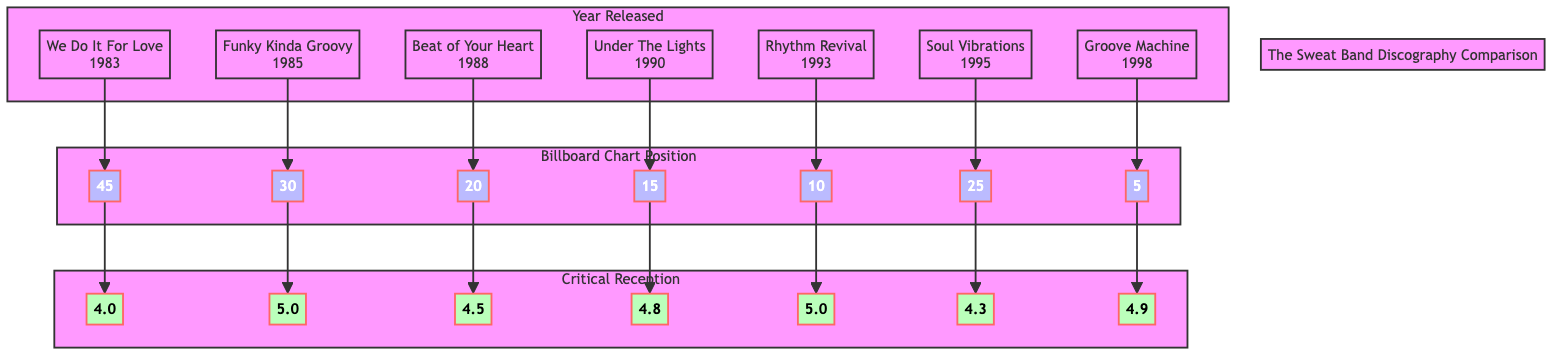What is the highest Billboard Chart Position achieved by The Sweat Band? The highest chart position in the "Billboard Chart Position" section is "5" for the album "Groove Machine" (GM). I identified the node labeled GM_C and looked for the highest numerical value listed.
Answer: 5 Which album received the lowest critical reception rating? The album with the lowest rating in the "Critical Reception" section is "We Do It For Love" (WDI) with a score of "4.0". I examined the values under the critical reception node and found the smallest number.
Answer: 4.0 How many albums did The Sweat Band release in the 1990s? The albums released in the 1990s are "Under The Lights," "Rhythm Revival," and "Soul Vibrations," totaling "3" albums. I counted the albums released in the years that fall within that decade as indicated in the diagram.
Answer: 3 What was the critical reception rating for "Rhythm Revival"? The critical reception for "Rhythm Revival" (RR) is "5.0." I examined the corresponding node below the "Critical Reception" subgraph to find the rating linked to RR.
Answer: 5.0 Which album had a Billboard Chart Position of 30? The album with a Billboard Chart Position of "30" is "Funky Kinda Groovy" (FKG). I looked through the values in the "Billboard Chart Position" section and matched the number with its corresponding album node.
Answer: Funky Kinda Groovy What is the relationship between "Beat of Your Heart" and its critical reception? "Beat of Your Heart" (BOY) has a critical reception rating of "4.5." I traced the connection from BOY to its critical reception rating node and noted the value.
Answer: 4.5 Which album has the best critical reception rating? "Rhythm Revival" (RR) and "Funky Kinda Groovy" (FKG) both have the highest critical reception rating of "5.0." I reviewed the critical reception values and noted the highest ones are tied between these two albums.
Answer: 5.0 How does the chart position of "Groove Machine" compare to "Soul Vibrations"? "Groove Machine" (GM) has a chart position of "5," while "Soul Vibrations" (SV) has a chart position of "25." I compared the values from the chart position nodes for both albums. The relationship shows that GM ranks significantly higher.
Answer: Groove Machine is higher 